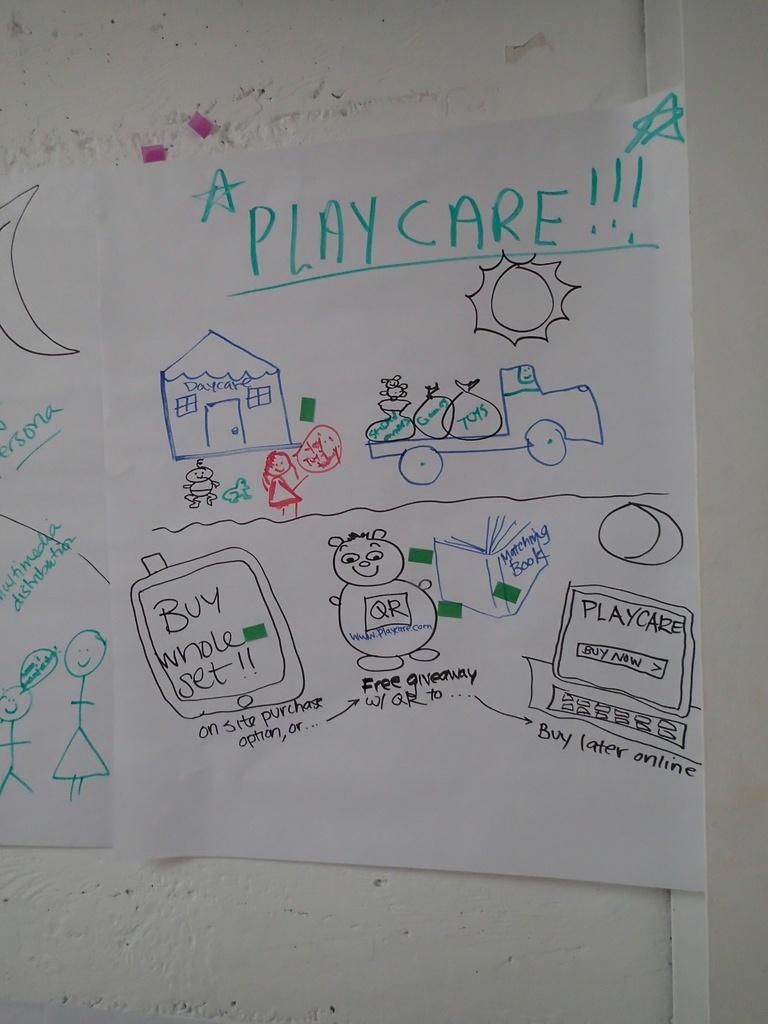Provide a one-sentence caption for the provided image. A piece of paper says "PLAY CARE!!!" and has drawings of a house and truck on it. 